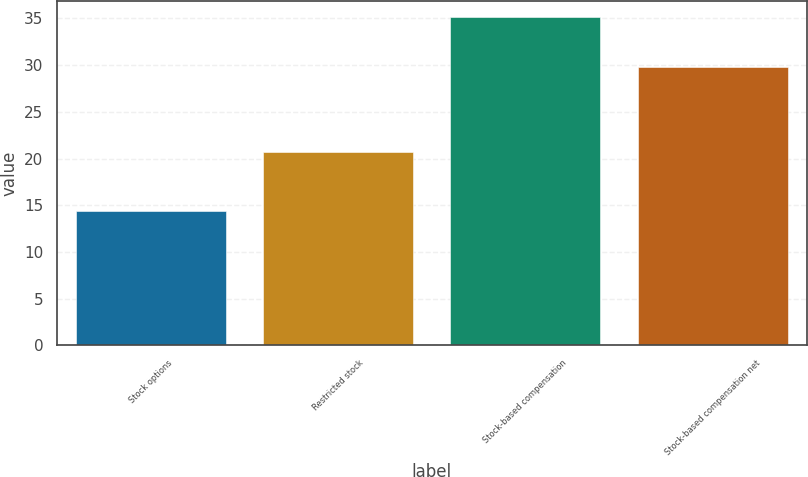Convert chart. <chart><loc_0><loc_0><loc_500><loc_500><bar_chart><fcel>Stock options<fcel>Restricted stock<fcel>Stock-based compensation<fcel>Stock-based compensation net<nl><fcel>14.4<fcel>20.7<fcel>35.1<fcel>29.8<nl></chart> 